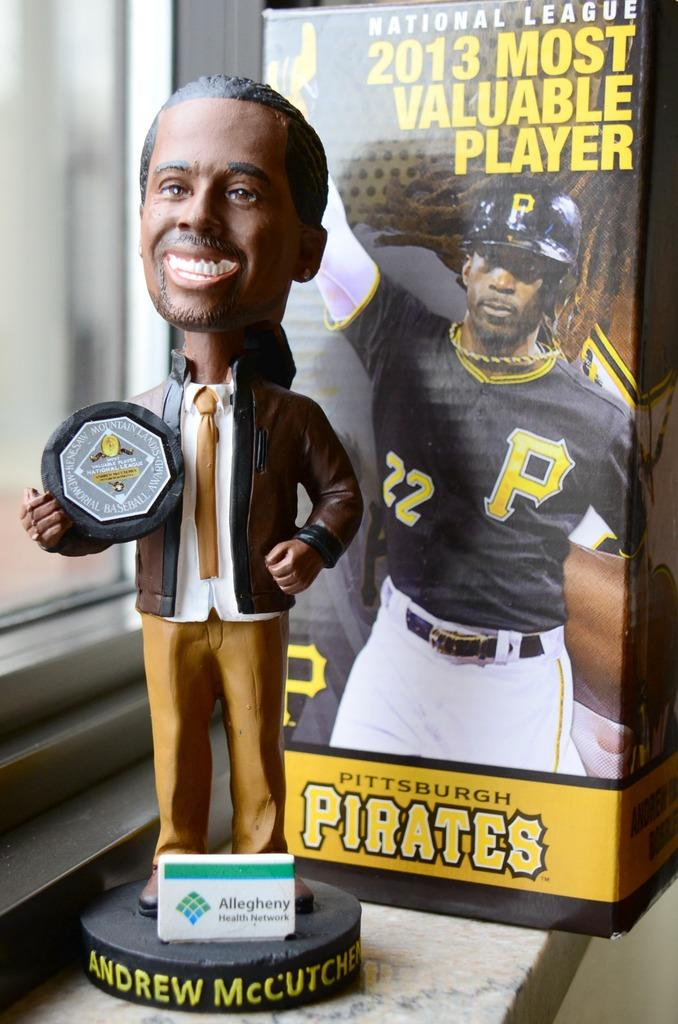What is the main subject of the image? There is a statue of a man in the image. What is the man holding in the image? The man is holding an object in the image. What can be seen on the platform in the image? There is a board with text on a platform in the image. What type of signage is visible in the image? There is a banner visible in the image. What architectural feature can be seen in the image? There is a glass window in the image. What type of learning environment is depicted in the image? The image does not depict a learning environment; it features a statue of a man holding an object, a board with text, a banner, and a glass window. How quiet is the scene in the image? The image does not provide any information about the noise level or the atmosphere of the scene. 